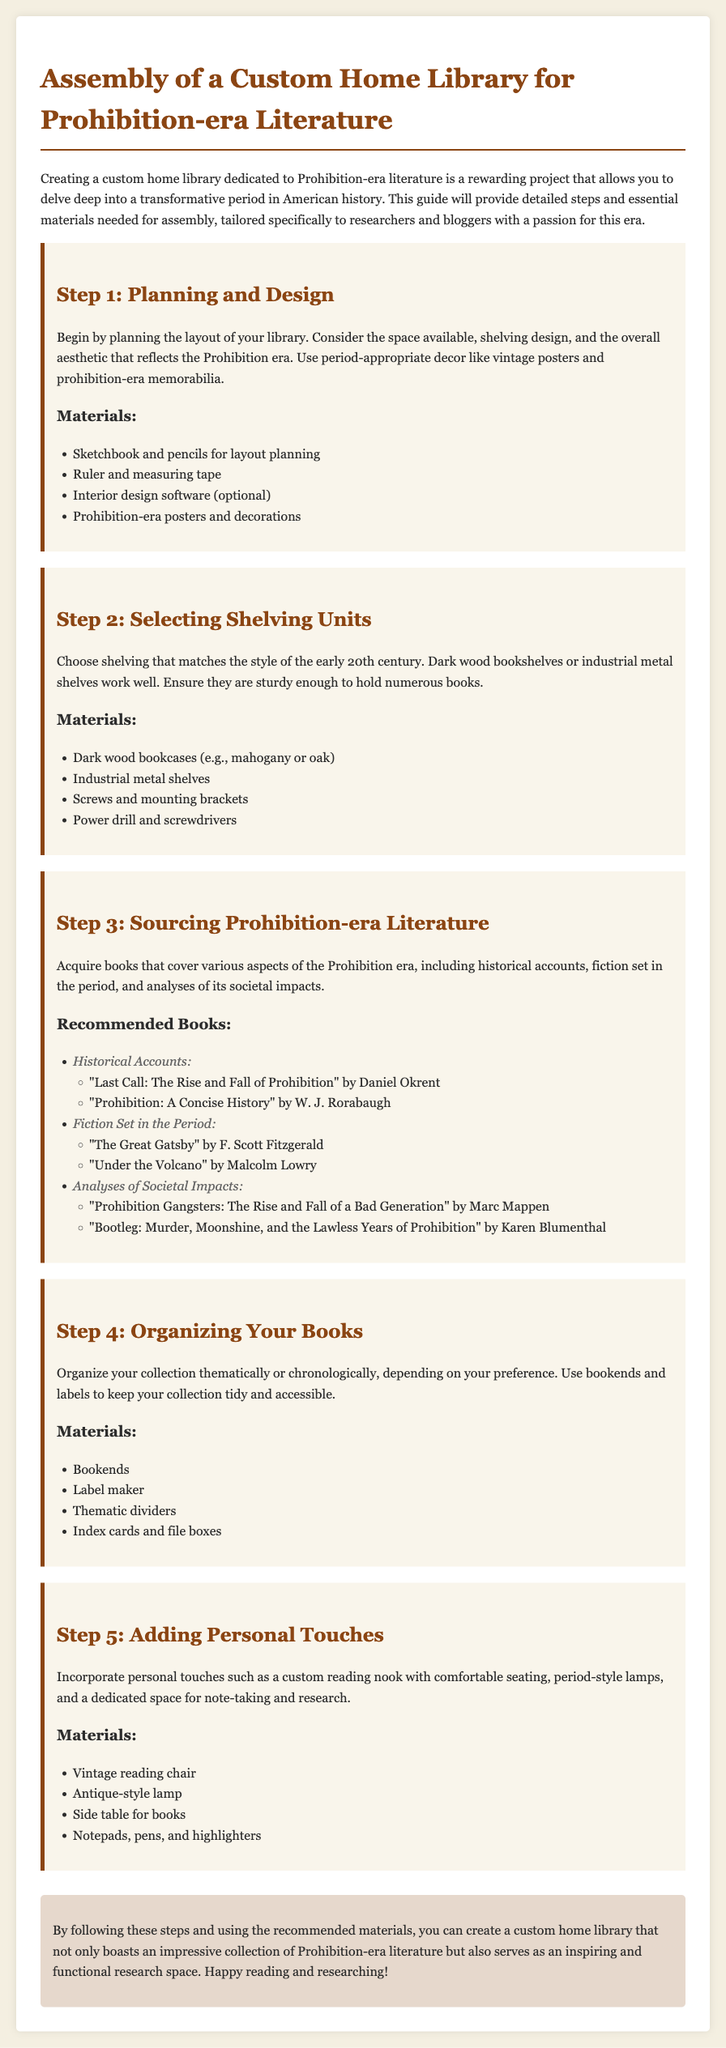What is the main purpose of the document? The document is a guide for creating a custom home library specifically dedicated to Prohibition-era literature.
Answer: Custom home library for Prohibition-era literature What color are the recommended bookcases? The document suggests using dark wood bookcases such as mahogany or oak.
Answer: Dark wood How many steps are outlined in the assembly instructions? The document lists five steps for assembling the library.
Answer: Five steps Which book by Daniel Okrent is recommended? The document mentions "Last Call: The Rise and Fall of Prohibition" as a recommended historical account.
Answer: Last Call: The Rise and Fall of Prohibition What type of lighting should be added for personal touches? The document suggests incorporating period-style lamps as part of the personal touches.
Answer: Antique-style lamp What tool is recommended for mounting shelves? The assembly instructions advise using a power drill and screwdrivers for mounting the shelves.
Answer: Power drill How should the books be organized according to the document? The guide suggests organizing the collection thematically or chronologically.
Answer: Thematically or chronologically What does the conclusion encourage readers to do? The conclusion encourages readers to enjoy reading and researching in their newly created library.
Answer: Happy reading and researching! 